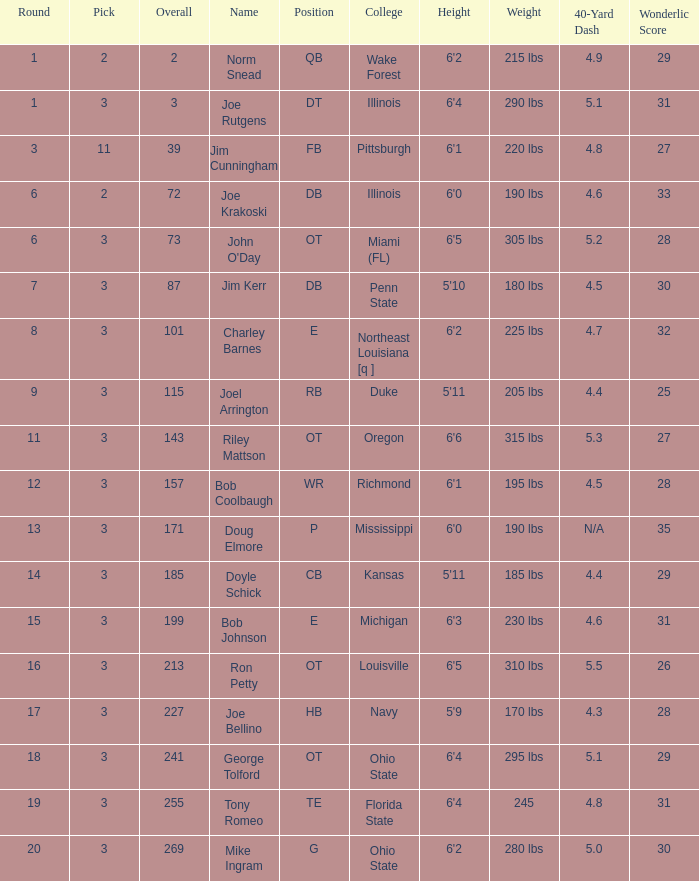How many rounds have john o'day as the name, and a pick less than 3? None. 